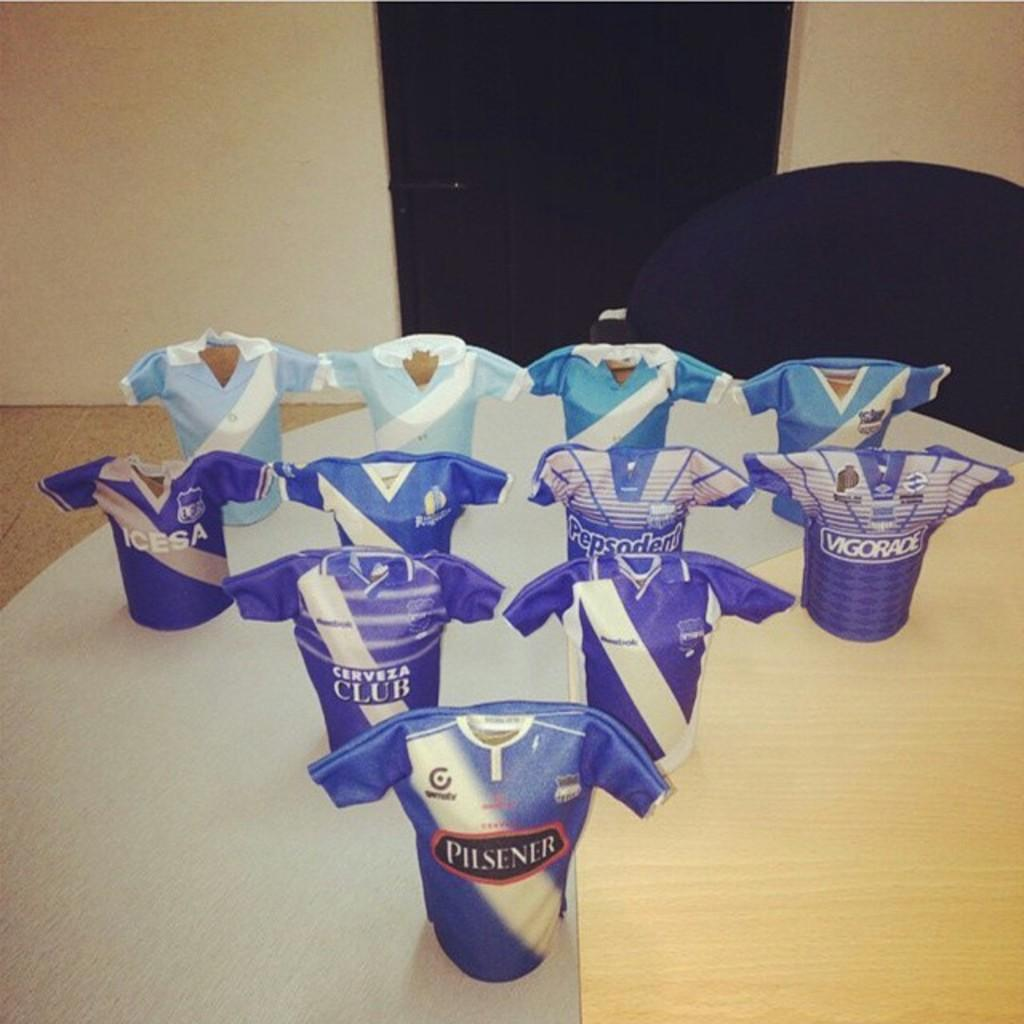<image>
Describe the image concisely. Mini jerseys with Pilsner written on them sit on a table top 